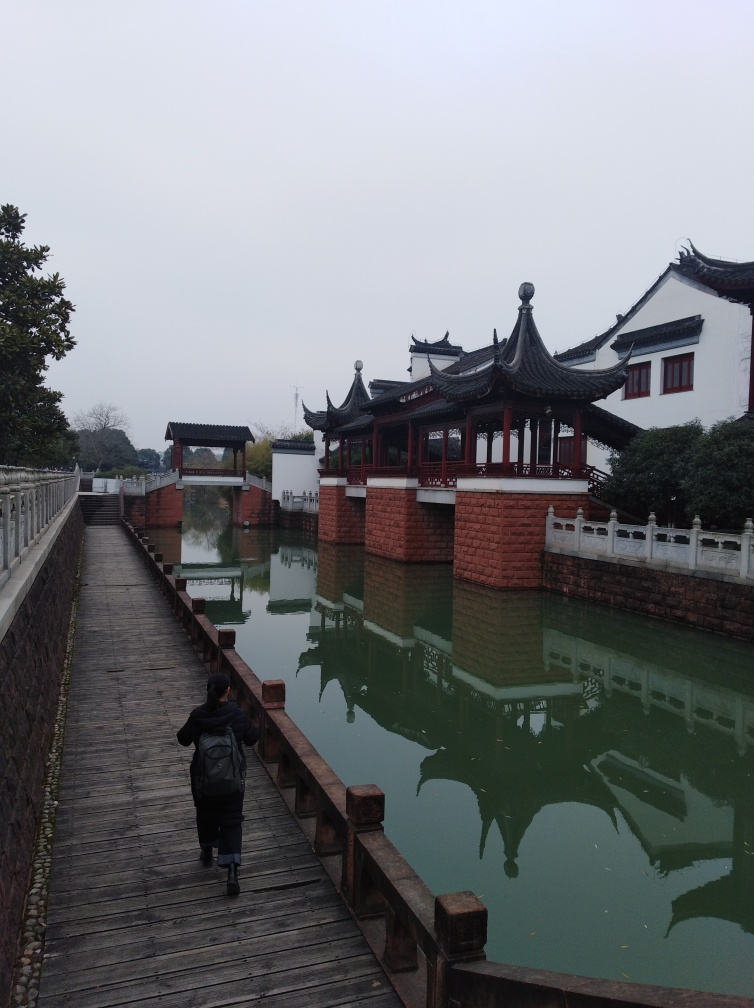Are the texture details on the ground rich? The texture details on the wooden walkway in the image are moderately rich; you can observe the grain patterns and the worn-out areas where the varnish has come off, indicating frequent use. The reflective surface of the water also displays texture by mirroring the traditional architecture and cloudy sky, offering a sense of tranquility and depth to the scene. 